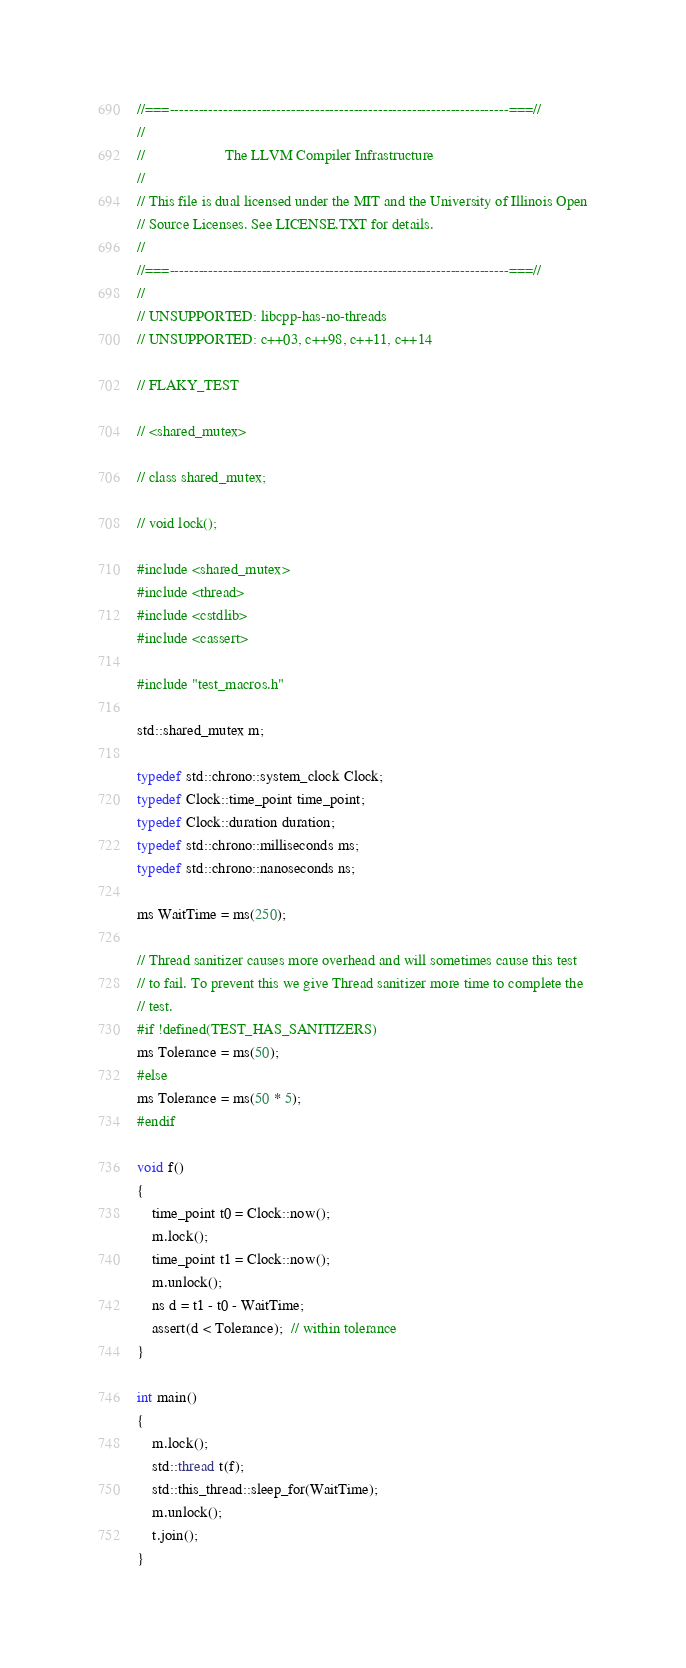Convert code to text. <code><loc_0><loc_0><loc_500><loc_500><_C++_>//===----------------------------------------------------------------------===//
//
//                     The LLVM Compiler Infrastructure
//
// This file is dual licensed under the MIT and the University of Illinois Open
// Source Licenses. See LICENSE.TXT for details.
//
//===----------------------------------------------------------------------===//
//
// UNSUPPORTED: libcpp-has-no-threads
// UNSUPPORTED: c++03, c++98, c++11, c++14

// FLAKY_TEST

// <shared_mutex>

// class shared_mutex;

// void lock();

#include <shared_mutex>
#include <thread>
#include <cstdlib>
#include <cassert>

#include "test_macros.h"

std::shared_mutex m;

typedef std::chrono::system_clock Clock;
typedef Clock::time_point time_point;
typedef Clock::duration duration;
typedef std::chrono::milliseconds ms;
typedef std::chrono::nanoseconds ns;

ms WaitTime = ms(250);

// Thread sanitizer causes more overhead and will sometimes cause this test
// to fail. To prevent this we give Thread sanitizer more time to complete the
// test.
#if !defined(TEST_HAS_SANITIZERS)
ms Tolerance = ms(50);
#else
ms Tolerance = ms(50 * 5);
#endif

void f()
{
    time_point t0 = Clock::now();
    m.lock();
    time_point t1 = Clock::now();
    m.unlock();
    ns d = t1 - t0 - WaitTime;
    assert(d < Tolerance);  // within tolerance
}

int main()
{
    m.lock();
    std::thread t(f);
    std::this_thread::sleep_for(WaitTime);
    m.unlock();
    t.join();
}
</code> 